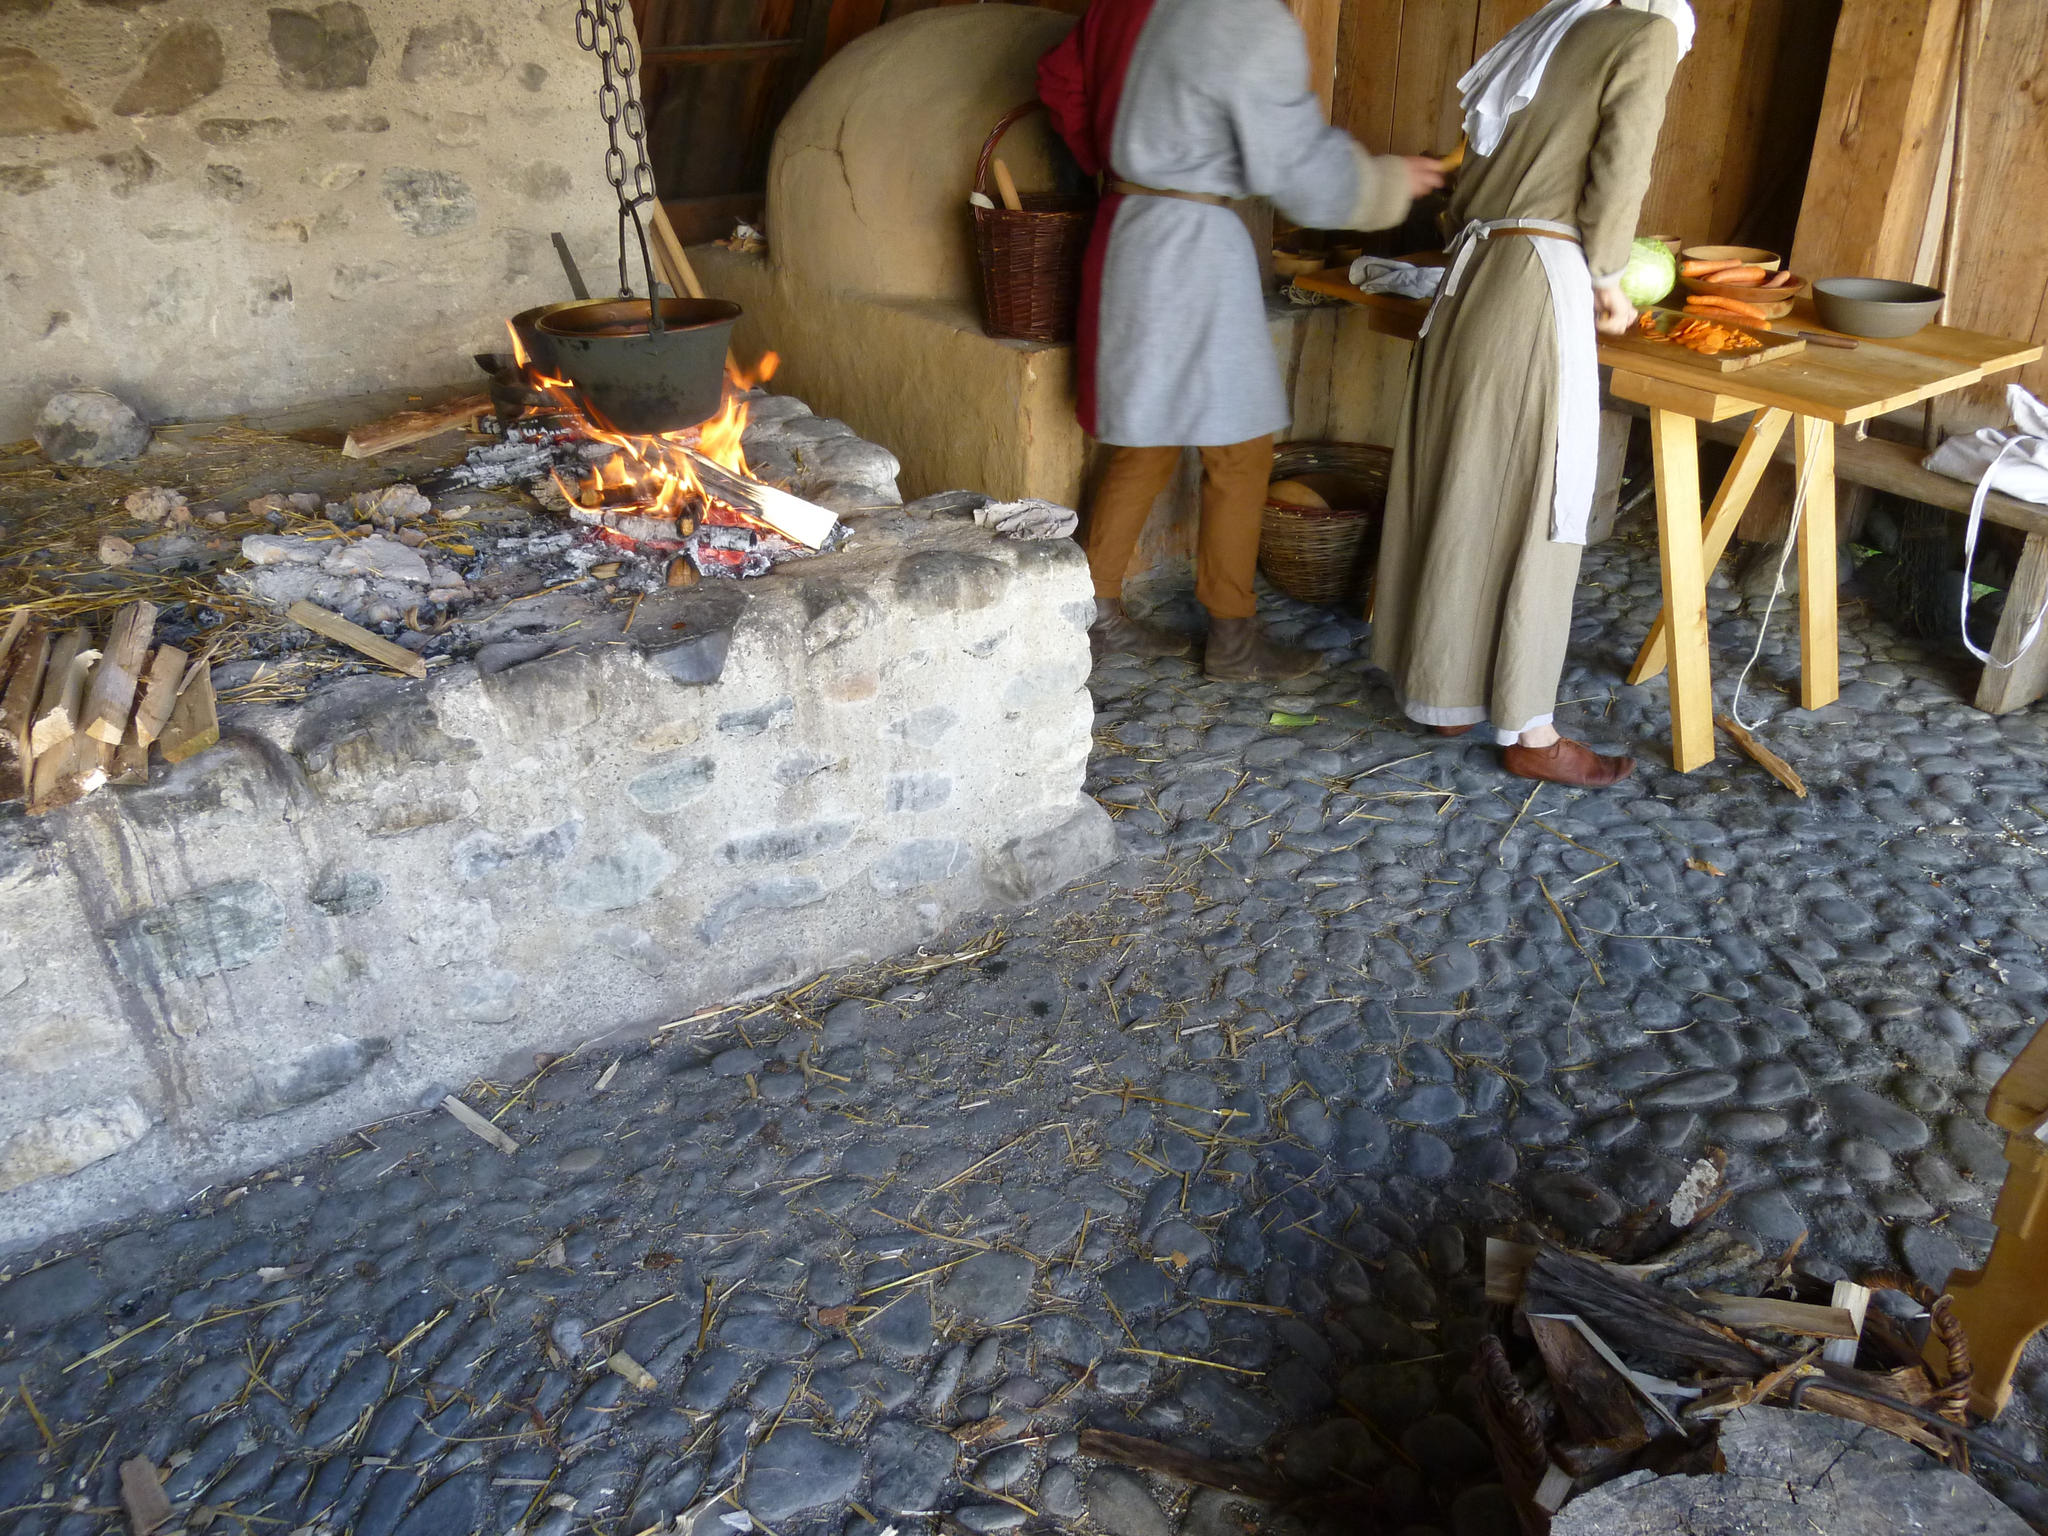How would you summarize this image in a sentence or two? In this image I can see a stone fence, wood, vessel on a wooden stove, benches, table on which vessel, vegetables are there and two persons are standing on the floor. In the background I can see a wall, basket and so on. This image is taken may be in a hall. 